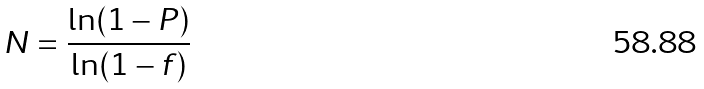Convert formula to latex. <formula><loc_0><loc_0><loc_500><loc_500>N = \frac { \ln ( 1 - P ) } { \ln ( 1 - f ) }</formula> 